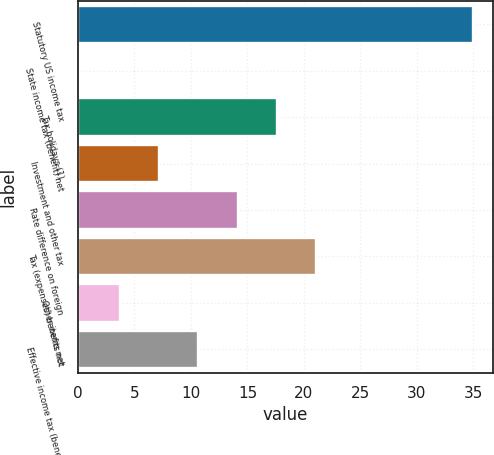Convert chart to OTSL. <chart><loc_0><loc_0><loc_500><loc_500><bar_chart><fcel>Statutory US income tax<fcel>State income tax (benefit) net<fcel>Tax holidays (1)<fcel>Investment and other tax<fcel>Rate difference on foreign<fcel>Tax (expenses) benefits not<fcel>Other items net<fcel>Effective income tax (benefit)<nl><fcel>35<fcel>0.2<fcel>17.6<fcel>7.16<fcel>14.12<fcel>21.08<fcel>3.68<fcel>10.64<nl></chart> 